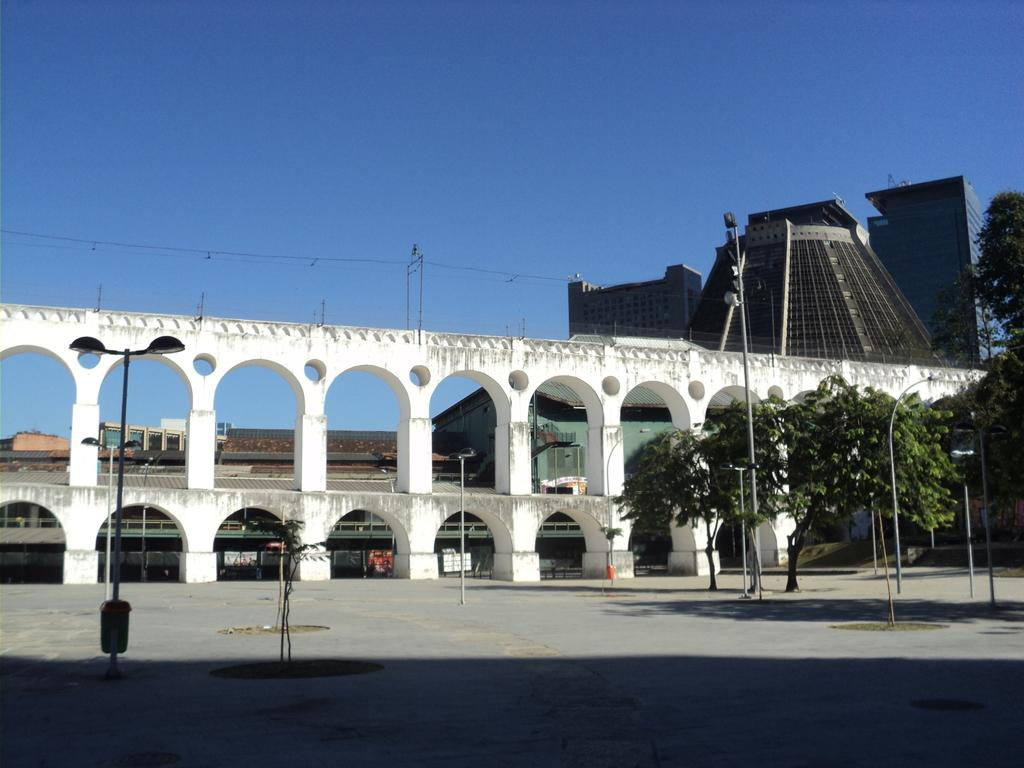What can be seen in the foreground of the image? In the foreground of the image, there is a road, trees, poles, and plants. Can you describe the background of the image? In the background of the image, there is an arch wall, buildings, and the sky is visible. What feeling does the addition of a new building in the image evoke? There is no mention of a new building being added in the image, so it is not possible to determine the feeling it would evoke. 